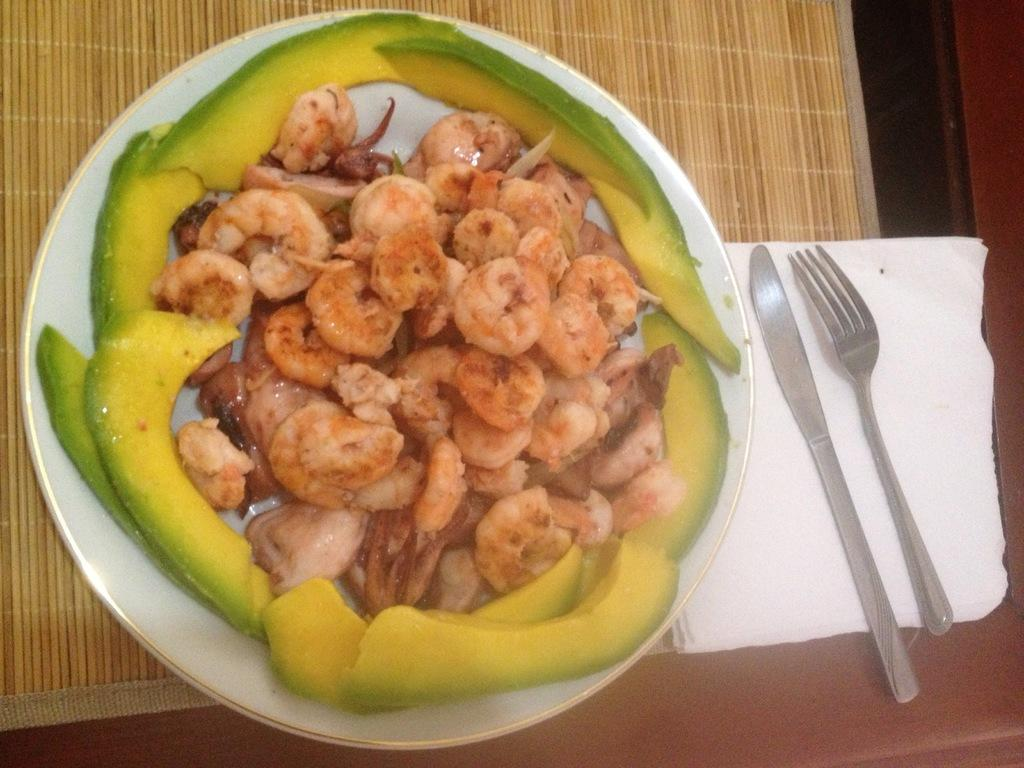What piece of furniture is in the image? There is a table in the image. What is placed on the table? There is a plate on the table. What can be used for cleaning or wiping on the table? Tissue papers are present on the table. What utensils are visible on the table? A knife and a fork are visible on the table. What is in the plate on the table? There is food in the plate. What type of trousers can be seen hanging on the chair in the image? There are no trousers present in the image; it only features a table, plate, tissue papers, a knife, a fork, and food. What fruit is being served in the plate in the image? There is no fruit visible in the plate; it contains food, but the specific type of food is not mentioned. 